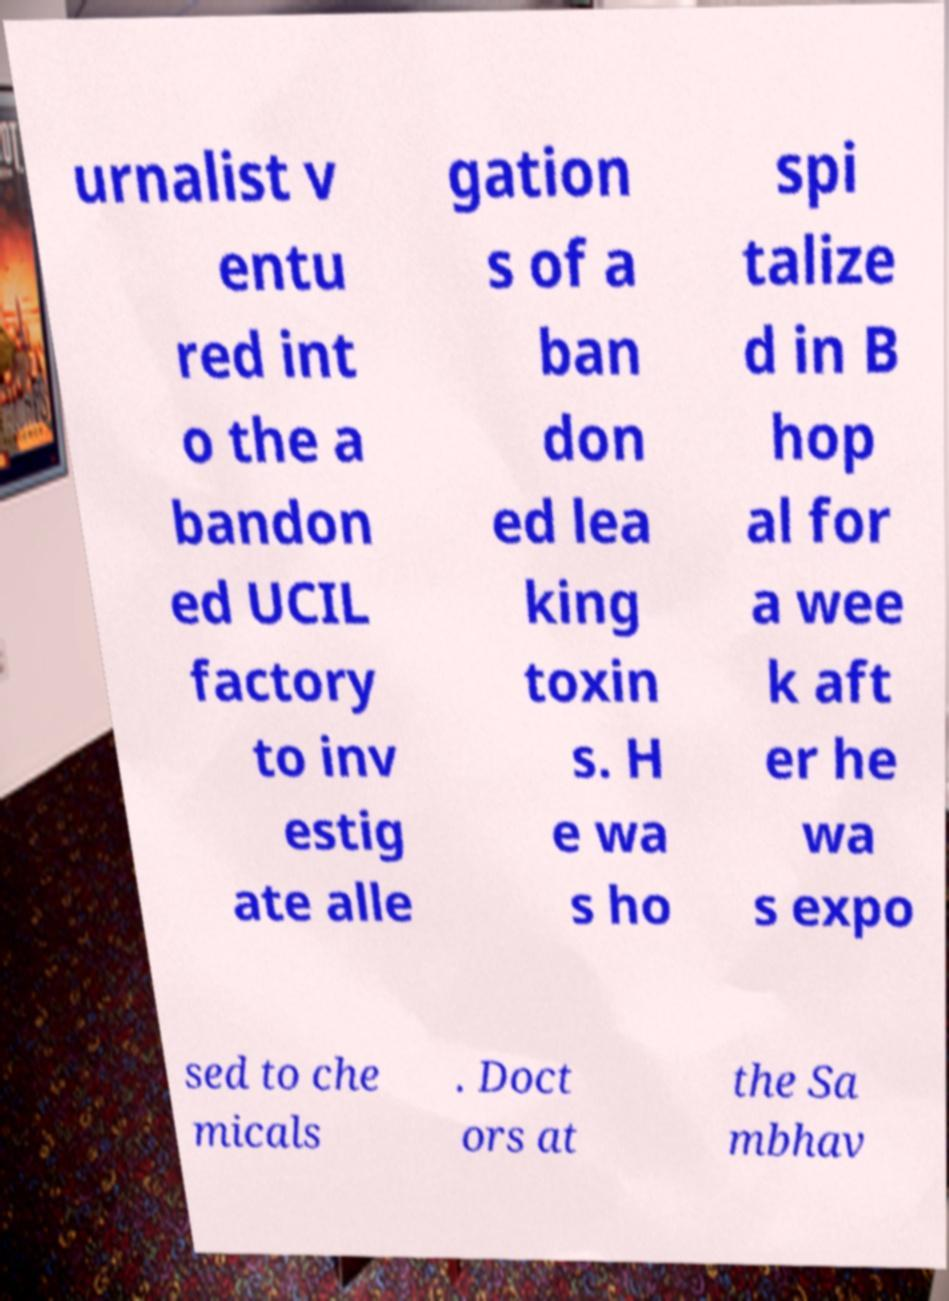Can you accurately transcribe the text from the provided image for me? urnalist v entu red int o the a bandon ed UCIL factory to inv estig ate alle gation s of a ban don ed lea king toxin s. H e wa s ho spi talize d in B hop al for a wee k aft er he wa s expo sed to che micals . Doct ors at the Sa mbhav 